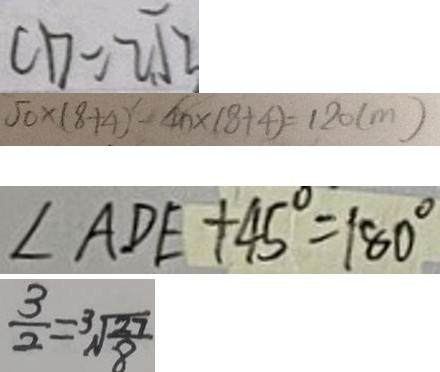Convert formula to latex. <formula><loc_0><loc_0><loc_500><loc_500>C D = 2 \sqrt { 3 } 
 5 0 \times ( 8 + 4 ) - 4 0 \times ( 8 + 4 ) = 1 2 0 ( m ) 
 \angle A D E + 4 5 ^ { \circ } = 1 8 0 ^ { \circ } 
 \frac { 3 } { 2 } = \sqrt [ 3 ] { \frac { 2 7 } { 8 } }</formula> 